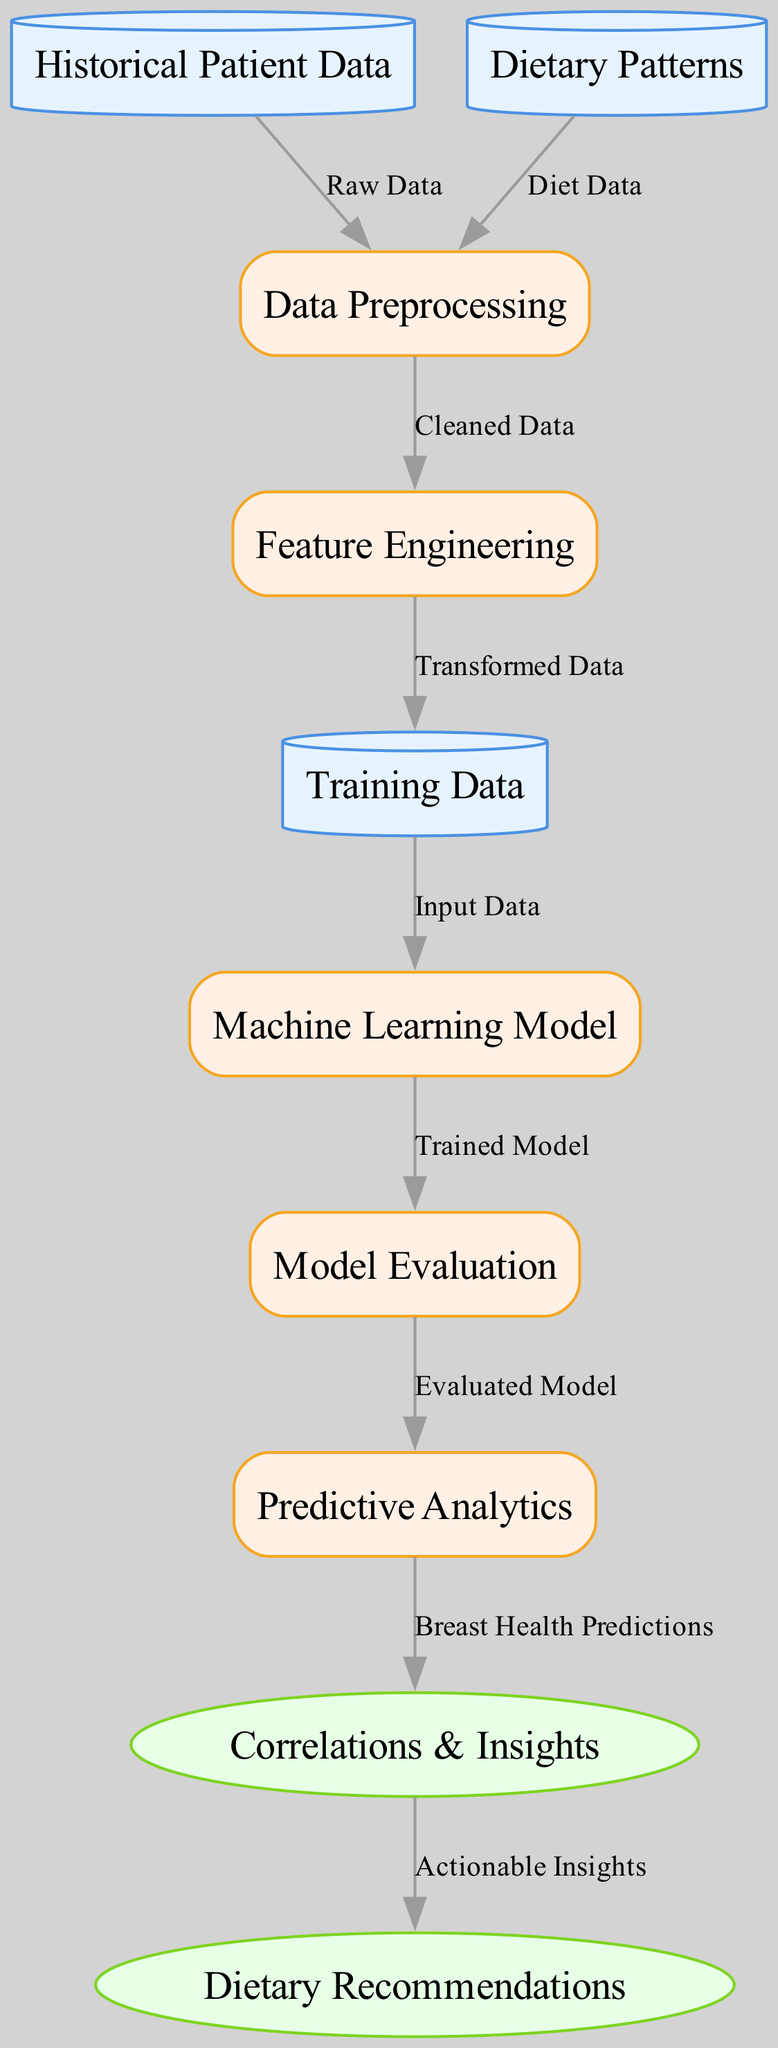What is the final output node in the diagram? The final output node is reached after following the flow from the earlier nodes through the evaluation of the model and predictive analytics. It is clearly labeled "Dietary Recommendations."
Answer: Dietary Recommendations How many data sources are present in the diagram? There are three data sources identified in the diagram: "Historical Patient Data," "Dietary Patterns," and "Training Data." By counting the nodes of type "data_source," we can determine the total.
Answer: Three What operation occurs after "Feature Engineering"? The flow from "Feature Engineering" leads to the next operation, which is "Training Data." This indicates that the transformed data output from feature engineering is then directed to the training data phase.
Answer: Training Data What connections exist from the "Machine Learning Model"? The "Machine Learning Model" has one outgoing connection labeled "Trained Model" which leads to "Model Evaluation." This indicates that the model is evaluated after it has been trained.
Answer: Model Evaluation What type of node is "Preprocessing"? The node "Preprocessing" is classified as an operation node in the diagram, as indicated by its label and the type assigned in the data structure.
Answer: Operation Describe the flow from "Model Evaluation" to "Correlations & Insights." "Model Evaluation" outputs an evaluated model which then flows into "Predictive Analytics." The predictions derived from predictive analytics are then directed to "Correlations & Insights," connecting the evaluation phase with the insights phase.
Answer: Correlations & Insights What do "Correlations & Insights" lead to? After analyzing the correlations and insights, the diagram indicates that the flow proceeds to "Dietary Recommendations," which represents actionable insights.
Answer: Dietary Recommendations Which node is directly connected to "Historical Patient Data"? "Preprocessing" is the node that is directly connected to "Historical Patient Data." This connection shows that the raw data is processed immediately after being sourced.
Answer: Preprocessing What type of data enters the "Machine Learning Model"? The model receives "Input Data" from the "Training Data" node, which is the processed and prepared dataset designed to train the machine learning model.
Answer: Input Data 